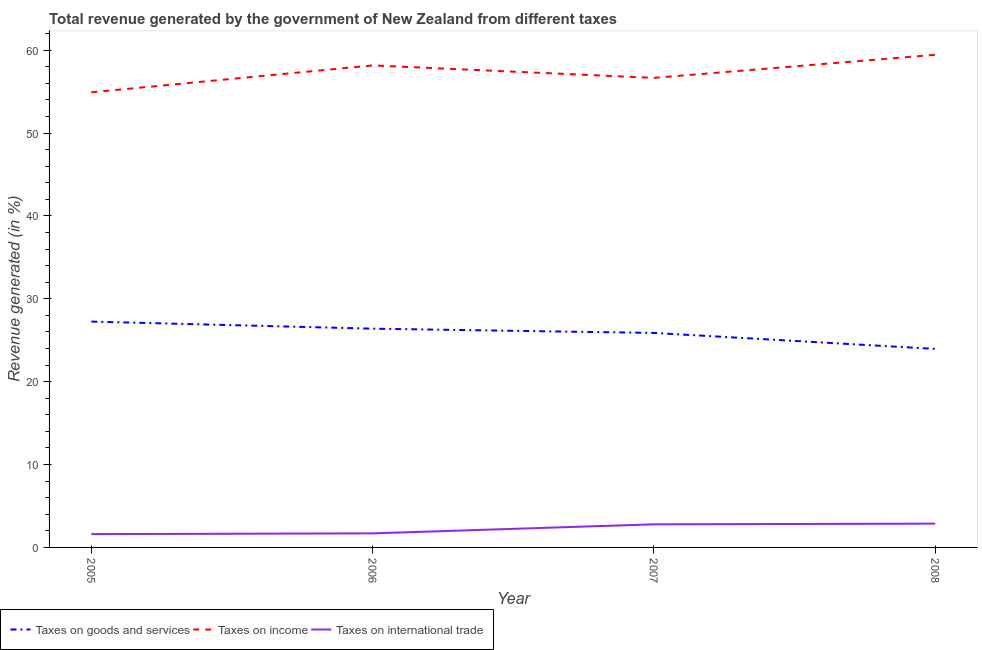Does the line corresponding to percentage of revenue generated by taxes on goods and services intersect with the line corresponding to percentage of revenue generated by taxes on income?
Your answer should be very brief. No. What is the percentage of revenue generated by tax on international trade in 2005?
Your answer should be very brief. 1.61. Across all years, what is the maximum percentage of revenue generated by tax on international trade?
Offer a very short reply. 2.87. Across all years, what is the minimum percentage of revenue generated by tax on international trade?
Your answer should be very brief. 1.61. In which year was the percentage of revenue generated by taxes on goods and services maximum?
Give a very brief answer. 2005. In which year was the percentage of revenue generated by tax on international trade minimum?
Provide a short and direct response. 2005. What is the total percentage of revenue generated by tax on international trade in the graph?
Your response must be concise. 8.96. What is the difference between the percentage of revenue generated by taxes on income in 2006 and that in 2007?
Provide a succinct answer. 1.5. What is the difference between the percentage of revenue generated by tax on international trade in 2008 and the percentage of revenue generated by taxes on income in 2005?
Keep it short and to the point. -52.06. What is the average percentage of revenue generated by taxes on goods and services per year?
Your answer should be very brief. 25.87. In the year 2005, what is the difference between the percentage of revenue generated by tax on international trade and percentage of revenue generated by taxes on goods and services?
Provide a succinct answer. -25.65. What is the ratio of the percentage of revenue generated by tax on international trade in 2005 to that in 2006?
Offer a very short reply. 0.95. Is the percentage of revenue generated by tax on international trade in 2006 less than that in 2007?
Offer a terse response. Yes. What is the difference between the highest and the second highest percentage of revenue generated by taxes on income?
Make the answer very short. 1.28. What is the difference between the highest and the lowest percentage of revenue generated by taxes on income?
Provide a succinct answer. 4.53. Is the sum of the percentage of revenue generated by taxes on goods and services in 2006 and 2008 greater than the maximum percentage of revenue generated by taxes on income across all years?
Your answer should be very brief. No. Is it the case that in every year, the sum of the percentage of revenue generated by taxes on goods and services and percentage of revenue generated by taxes on income is greater than the percentage of revenue generated by tax on international trade?
Provide a short and direct response. Yes. Does the percentage of revenue generated by taxes on income monotonically increase over the years?
Your answer should be very brief. No. Is the percentage of revenue generated by taxes on income strictly less than the percentage of revenue generated by taxes on goods and services over the years?
Your answer should be very brief. No. How many lines are there?
Your answer should be very brief. 3. What is the difference between two consecutive major ticks on the Y-axis?
Give a very brief answer. 10. Does the graph contain any zero values?
Your answer should be very brief. No. Where does the legend appear in the graph?
Make the answer very short. Bottom left. How many legend labels are there?
Make the answer very short. 3. What is the title of the graph?
Your response must be concise. Total revenue generated by the government of New Zealand from different taxes. What is the label or title of the X-axis?
Your answer should be compact. Year. What is the label or title of the Y-axis?
Make the answer very short. Revenue generated (in %). What is the Revenue generated (in %) in Taxes on goods and services in 2005?
Provide a succinct answer. 27.26. What is the Revenue generated (in %) of Taxes on income in 2005?
Offer a terse response. 54.93. What is the Revenue generated (in %) in Taxes on international trade in 2005?
Provide a short and direct response. 1.61. What is the Revenue generated (in %) in Taxes on goods and services in 2006?
Offer a terse response. 26.4. What is the Revenue generated (in %) in Taxes on income in 2006?
Provide a succinct answer. 58.17. What is the Revenue generated (in %) in Taxes on international trade in 2006?
Provide a succinct answer. 1.7. What is the Revenue generated (in %) of Taxes on goods and services in 2007?
Ensure brevity in your answer.  25.89. What is the Revenue generated (in %) of Taxes on income in 2007?
Keep it short and to the point. 56.67. What is the Revenue generated (in %) in Taxes on international trade in 2007?
Your response must be concise. 2.79. What is the Revenue generated (in %) in Taxes on goods and services in 2008?
Provide a short and direct response. 23.96. What is the Revenue generated (in %) in Taxes on income in 2008?
Keep it short and to the point. 59.45. What is the Revenue generated (in %) in Taxes on international trade in 2008?
Your answer should be compact. 2.87. Across all years, what is the maximum Revenue generated (in %) in Taxes on goods and services?
Give a very brief answer. 27.26. Across all years, what is the maximum Revenue generated (in %) of Taxes on income?
Offer a terse response. 59.45. Across all years, what is the maximum Revenue generated (in %) in Taxes on international trade?
Offer a terse response. 2.87. Across all years, what is the minimum Revenue generated (in %) of Taxes on goods and services?
Give a very brief answer. 23.96. Across all years, what is the minimum Revenue generated (in %) of Taxes on income?
Ensure brevity in your answer.  54.93. Across all years, what is the minimum Revenue generated (in %) in Taxes on international trade?
Give a very brief answer. 1.61. What is the total Revenue generated (in %) in Taxes on goods and services in the graph?
Your answer should be very brief. 103.5. What is the total Revenue generated (in %) of Taxes on income in the graph?
Make the answer very short. 229.22. What is the total Revenue generated (in %) in Taxes on international trade in the graph?
Keep it short and to the point. 8.96. What is the difference between the Revenue generated (in %) of Taxes on goods and services in 2005 and that in 2006?
Provide a short and direct response. 0.86. What is the difference between the Revenue generated (in %) of Taxes on income in 2005 and that in 2006?
Give a very brief answer. -3.25. What is the difference between the Revenue generated (in %) in Taxes on international trade in 2005 and that in 2006?
Your answer should be compact. -0.09. What is the difference between the Revenue generated (in %) of Taxes on goods and services in 2005 and that in 2007?
Provide a succinct answer. 1.37. What is the difference between the Revenue generated (in %) of Taxes on income in 2005 and that in 2007?
Ensure brevity in your answer.  -1.74. What is the difference between the Revenue generated (in %) in Taxes on international trade in 2005 and that in 2007?
Offer a very short reply. -1.18. What is the difference between the Revenue generated (in %) of Taxes on goods and services in 2005 and that in 2008?
Your response must be concise. 3.3. What is the difference between the Revenue generated (in %) in Taxes on income in 2005 and that in 2008?
Offer a very short reply. -4.53. What is the difference between the Revenue generated (in %) in Taxes on international trade in 2005 and that in 2008?
Offer a terse response. -1.26. What is the difference between the Revenue generated (in %) in Taxes on goods and services in 2006 and that in 2007?
Give a very brief answer. 0.51. What is the difference between the Revenue generated (in %) in Taxes on income in 2006 and that in 2007?
Offer a terse response. 1.5. What is the difference between the Revenue generated (in %) in Taxes on international trade in 2006 and that in 2007?
Your answer should be very brief. -1.09. What is the difference between the Revenue generated (in %) in Taxes on goods and services in 2006 and that in 2008?
Provide a succinct answer. 2.44. What is the difference between the Revenue generated (in %) in Taxes on income in 2006 and that in 2008?
Your response must be concise. -1.28. What is the difference between the Revenue generated (in %) of Taxes on international trade in 2006 and that in 2008?
Your answer should be compact. -1.17. What is the difference between the Revenue generated (in %) in Taxes on goods and services in 2007 and that in 2008?
Your response must be concise. 1.93. What is the difference between the Revenue generated (in %) of Taxes on income in 2007 and that in 2008?
Provide a succinct answer. -2.79. What is the difference between the Revenue generated (in %) of Taxes on international trade in 2007 and that in 2008?
Provide a short and direct response. -0.08. What is the difference between the Revenue generated (in %) in Taxes on goods and services in 2005 and the Revenue generated (in %) in Taxes on income in 2006?
Provide a succinct answer. -30.92. What is the difference between the Revenue generated (in %) of Taxes on goods and services in 2005 and the Revenue generated (in %) of Taxes on international trade in 2006?
Provide a succinct answer. 25.56. What is the difference between the Revenue generated (in %) in Taxes on income in 2005 and the Revenue generated (in %) in Taxes on international trade in 2006?
Your answer should be very brief. 53.23. What is the difference between the Revenue generated (in %) of Taxes on goods and services in 2005 and the Revenue generated (in %) of Taxes on income in 2007?
Make the answer very short. -29.41. What is the difference between the Revenue generated (in %) of Taxes on goods and services in 2005 and the Revenue generated (in %) of Taxes on international trade in 2007?
Your response must be concise. 24.47. What is the difference between the Revenue generated (in %) in Taxes on income in 2005 and the Revenue generated (in %) in Taxes on international trade in 2007?
Your response must be concise. 52.14. What is the difference between the Revenue generated (in %) of Taxes on goods and services in 2005 and the Revenue generated (in %) of Taxes on income in 2008?
Keep it short and to the point. -32.2. What is the difference between the Revenue generated (in %) of Taxes on goods and services in 2005 and the Revenue generated (in %) of Taxes on international trade in 2008?
Offer a very short reply. 24.38. What is the difference between the Revenue generated (in %) of Taxes on income in 2005 and the Revenue generated (in %) of Taxes on international trade in 2008?
Make the answer very short. 52.06. What is the difference between the Revenue generated (in %) in Taxes on goods and services in 2006 and the Revenue generated (in %) in Taxes on income in 2007?
Offer a very short reply. -30.27. What is the difference between the Revenue generated (in %) in Taxes on goods and services in 2006 and the Revenue generated (in %) in Taxes on international trade in 2007?
Your response must be concise. 23.61. What is the difference between the Revenue generated (in %) in Taxes on income in 2006 and the Revenue generated (in %) in Taxes on international trade in 2007?
Offer a very short reply. 55.38. What is the difference between the Revenue generated (in %) in Taxes on goods and services in 2006 and the Revenue generated (in %) in Taxes on income in 2008?
Your answer should be compact. -33.05. What is the difference between the Revenue generated (in %) in Taxes on goods and services in 2006 and the Revenue generated (in %) in Taxes on international trade in 2008?
Ensure brevity in your answer.  23.53. What is the difference between the Revenue generated (in %) in Taxes on income in 2006 and the Revenue generated (in %) in Taxes on international trade in 2008?
Ensure brevity in your answer.  55.3. What is the difference between the Revenue generated (in %) of Taxes on goods and services in 2007 and the Revenue generated (in %) of Taxes on income in 2008?
Your answer should be compact. -33.57. What is the difference between the Revenue generated (in %) in Taxes on goods and services in 2007 and the Revenue generated (in %) in Taxes on international trade in 2008?
Your answer should be compact. 23.01. What is the difference between the Revenue generated (in %) of Taxes on income in 2007 and the Revenue generated (in %) of Taxes on international trade in 2008?
Keep it short and to the point. 53.8. What is the average Revenue generated (in %) of Taxes on goods and services per year?
Provide a short and direct response. 25.87. What is the average Revenue generated (in %) in Taxes on income per year?
Your answer should be very brief. 57.3. What is the average Revenue generated (in %) in Taxes on international trade per year?
Your answer should be compact. 2.24. In the year 2005, what is the difference between the Revenue generated (in %) of Taxes on goods and services and Revenue generated (in %) of Taxes on income?
Make the answer very short. -27.67. In the year 2005, what is the difference between the Revenue generated (in %) of Taxes on goods and services and Revenue generated (in %) of Taxes on international trade?
Your response must be concise. 25.65. In the year 2005, what is the difference between the Revenue generated (in %) in Taxes on income and Revenue generated (in %) in Taxes on international trade?
Give a very brief answer. 53.32. In the year 2006, what is the difference between the Revenue generated (in %) of Taxes on goods and services and Revenue generated (in %) of Taxes on income?
Your answer should be compact. -31.77. In the year 2006, what is the difference between the Revenue generated (in %) of Taxes on goods and services and Revenue generated (in %) of Taxes on international trade?
Make the answer very short. 24.7. In the year 2006, what is the difference between the Revenue generated (in %) of Taxes on income and Revenue generated (in %) of Taxes on international trade?
Offer a very short reply. 56.47. In the year 2007, what is the difference between the Revenue generated (in %) in Taxes on goods and services and Revenue generated (in %) in Taxes on income?
Your answer should be compact. -30.78. In the year 2007, what is the difference between the Revenue generated (in %) of Taxes on goods and services and Revenue generated (in %) of Taxes on international trade?
Your answer should be very brief. 23.1. In the year 2007, what is the difference between the Revenue generated (in %) of Taxes on income and Revenue generated (in %) of Taxes on international trade?
Make the answer very short. 53.88. In the year 2008, what is the difference between the Revenue generated (in %) in Taxes on goods and services and Revenue generated (in %) in Taxes on income?
Make the answer very short. -35.5. In the year 2008, what is the difference between the Revenue generated (in %) of Taxes on goods and services and Revenue generated (in %) of Taxes on international trade?
Your response must be concise. 21.09. In the year 2008, what is the difference between the Revenue generated (in %) of Taxes on income and Revenue generated (in %) of Taxes on international trade?
Ensure brevity in your answer.  56.58. What is the ratio of the Revenue generated (in %) in Taxes on goods and services in 2005 to that in 2006?
Your answer should be very brief. 1.03. What is the ratio of the Revenue generated (in %) of Taxes on income in 2005 to that in 2006?
Your response must be concise. 0.94. What is the ratio of the Revenue generated (in %) of Taxes on international trade in 2005 to that in 2006?
Make the answer very short. 0.95. What is the ratio of the Revenue generated (in %) in Taxes on goods and services in 2005 to that in 2007?
Provide a short and direct response. 1.05. What is the ratio of the Revenue generated (in %) in Taxes on income in 2005 to that in 2007?
Make the answer very short. 0.97. What is the ratio of the Revenue generated (in %) in Taxes on international trade in 2005 to that in 2007?
Keep it short and to the point. 0.58. What is the ratio of the Revenue generated (in %) of Taxes on goods and services in 2005 to that in 2008?
Your answer should be compact. 1.14. What is the ratio of the Revenue generated (in %) in Taxes on income in 2005 to that in 2008?
Make the answer very short. 0.92. What is the ratio of the Revenue generated (in %) in Taxes on international trade in 2005 to that in 2008?
Your answer should be compact. 0.56. What is the ratio of the Revenue generated (in %) of Taxes on goods and services in 2006 to that in 2007?
Provide a succinct answer. 1.02. What is the ratio of the Revenue generated (in %) in Taxes on income in 2006 to that in 2007?
Your answer should be compact. 1.03. What is the ratio of the Revenue generated (in %) of Taxes on international trade in 2006 to that in 2007?
Give a very brief answer. 0.61. What is the ratio of the Revenue generated (in %) of Taxes on goods and services in 2006 to that in 2008?
Keep it short and to the point. 1.1. What is the ratio of the Revenue generated (in %) of Taxes on income in 2006 to that in 2008?
Offer a very short reply. 0.98. What is the ratio of the Revenue generated (in %) in Taxes on international trade in 2006 to that in 2008?
Your answer should be compact. 0.59. What is the ratio of the Revenue generated (in %) of Taxes on goods and services in 2007 to that in 2008?
Provide a short and direct response. 1.08. What is the ratio of the Revenue generated (in %) of Taxes on income in 2007 to that in 2008?
Your answer should be compact. 0.95. What is the ratio of the Revenue generated (in %) in Taxes on international trade in 2007 to that in 2008?
Give a very brief answer. 0.97. What is the difference between the highest and the second highest Revenue generated (in %) in Taxes on goods and services?
Your answer should be compact. 0.86. What is the difference between the highest and the second highest Revenue generated (in %) of Taxes on income?
Make the answer very short. 1.28. What is the difference between the highest and the second highest Revenue generated (in %) in Taxes on international trade?
Your answer should be very brief. 0.08. What is the difference between the highest and the lowest Revenue generated (in %) of Taxes on goods and services?
Give a very brief answer. 3.3. What is the difference between the highest and the lowest Revenue generated (in %) in Taxes on income?
Keep it short and to the point. 4.53. What is the difference between the highest and the lowest Revenue generated (in %) in Taxes on international trade?
Offer a very short reply. 1.26. 